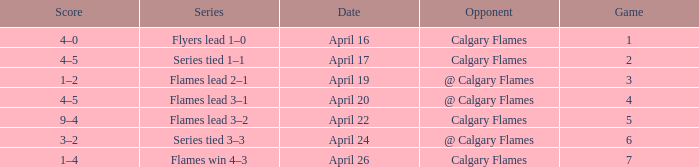Which Series has an Opponent of calgary flames, and a Score of 9–4? Flames lead 3–2. 